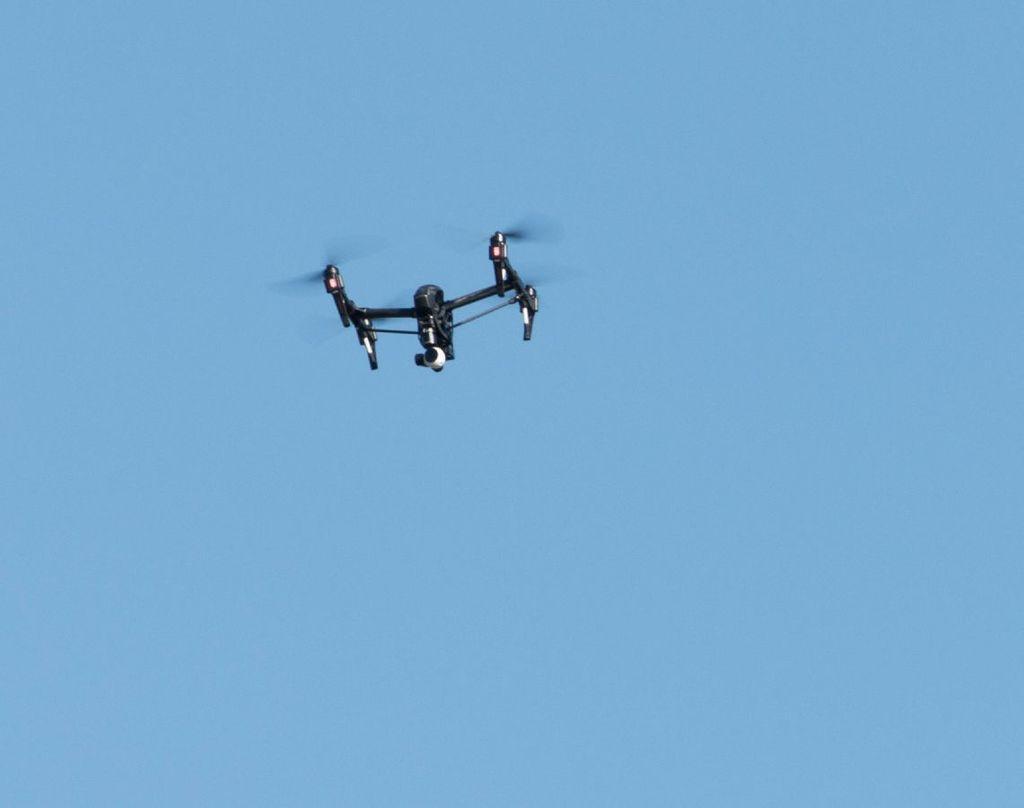In one or two sentences, can you explain what this image depicts? Here we can see an airplane. In the background there is sky. 